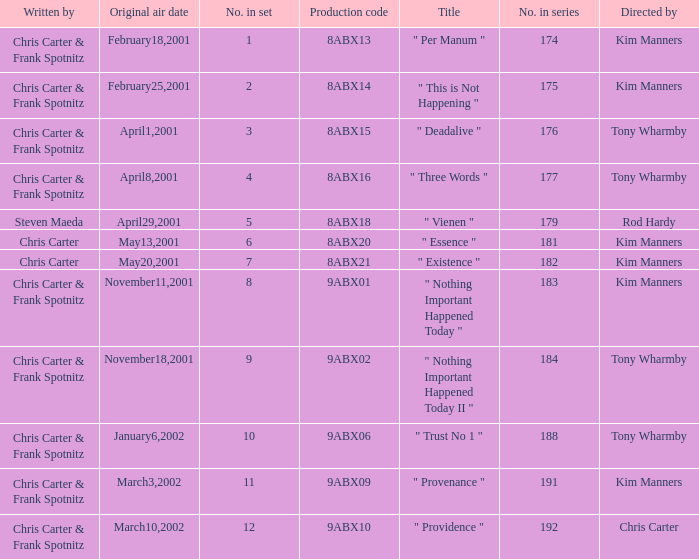What is the episode number that has production code 8abx15? 176.0. 